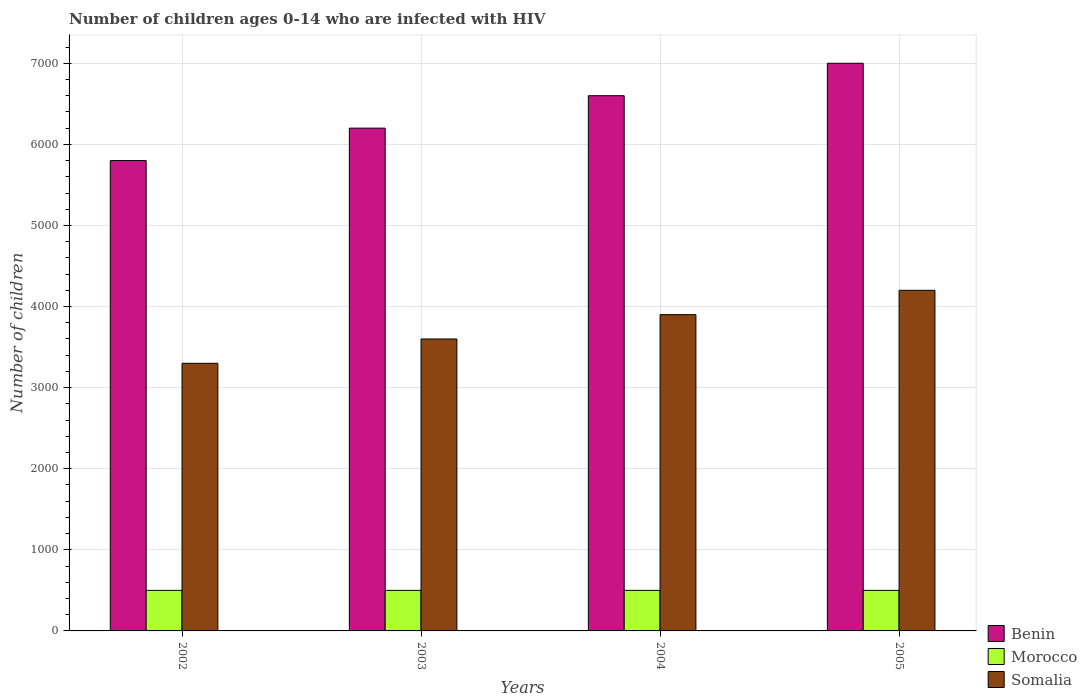How many different coloured bars are there?
Ensure brevity in your answer.  3. How many groups of bars are there?
Provide a succinct answer. 4. Are the number of bars on each tick of the X-axis equal?
Offer a terse response. Yes. How many bars are there on the 2nd tick from the right?
Your response must be concise. 3. In how many cases, is the number of bars for a given year not equal to the number of legend labels?
Provide a short and direct response. 0. What is the number of HIV infected children in Benin in 2004?
Offer a terse response. 6600. Across all years, what is the maximum number of HIV infected children in Morocco?
Your response must be concise. 500. Across all years, what is the minimum number of HIV infected children in Somalia?
Offer a very short reply. 3300. In which year was the number of HIV infected children in Benin maximum?
Offer a very short reply. 2005. What is the total number of HIV infected children in Somalia in the graph?
Provide a succinct answer. 1.50e+04. What is the difference between the number of HIV infected children in Benin in 2003 and that in 2005?
Keep it short and to the point. -800. What is the difference between the number of HIV infected children in Morocco in 2003 and the number of HIV infected children in Benin in 2004?
Give a very brief answer. -6100. What is the average number of HIV infected children in Somalia per year?
Give a very brief answer. 3750. In the year 2005, what is the difference between the number of HIV infected children in Somalia and number of HIV infected children in Benin?
Your response must be concise. -2800. What is the ratio of the number of HIV infected children in Morocco in 2002 to that in 2003?
Ensure brevity in your answer.  1. Is the difference between the number of HIV infected children in Somalia in 2002 and 2004 greater than the difference between the number of HIV infected children in Benin in 2002 and 2004?
Offer a terse response. Yes. What is the difference between the highest and the second highest number of HIV infected children in Morocco?
Provide a short and direct response. 0. What is the difference between the highest and the lowest number of HIV infected children in Morocco?
Provide a succinct answer. 0. In how many years, is the number of HIV infected children in Somalia greater than the average number of HIV infected children in Somalia taken over all years?
Offer a terse response. 2. What does the 3rd bar from the left in 2005 represents?
Your response must be concise. Somalia. What does the 1st bar from the right in 2005 represents?
Give a very brief answer. Somalia. Is it the case that in every year, the sum of the number of HIV infected children in Somalia and number of HIV infected children in Benin is greater than the number of HIV infected children in Morocco?
Give a very brief answer. Yes. How many bars are there?
Your answer should be very brief. 12. How many legend labels are there?
Keep it short and to the point. 3. How are the legend labels stacked?
Keep it short and to the point. Vertical. What is the title of the graph?
Make the answer very short. Number of children ages 0-14 who are infected with HIV. What is the label or title of the Y-axis?
Provide a succinct answer. Number of children. What is the Number of children of Benin in 2002?
Make the answer very short. 5800. What is the Number of children of Somalia in 2002?
Provide a short and direct response. 3300. What is the Number of children of Benin in 2003?
Provide a succinct answer. 6200. What is the Number of children in Morocco in 2003?
Give a very brief answer. 500. What is the Number of children in Somalia in 2003?
Keep it short and to the point. 3600. What is the Number of children of Benin in 2004?
Your answer should be very brief. 6600. What is the Number of children of Somalia in 2004?
Your answer should be very brief. 3900. What is the Number of children in Benin in 2005?
Provide a succinct answer. 7000. What is the Number of children of Somalia in 2005?
Give a very brief answer. 4200. Across all years, what is the maximum Number of children of Benin?
Provide a succinct answer. 7000. Across all years, what is the maximum Number of children of Somalia?
Ensure brevity in your answer.  4200. Across all years, what is the minimum Number of children in Benin?
Your response must be concise. 5800. Across all years, what is the minimum Number of children in Morocco?
Keep it short and to the point. 500. Across all years, what is the minimum Number of children in Somalia?
Provide a short and direct response. 3300. What is the total Number of children of Benin in the graph?
Provide a succinct answer. 2.56e+04. What is the total Number of children of Somalia in the graph?
Make the answer very short. 1.50e+04. What is the difference between the Number of children in Benin in 2002 and that in 2003?
Offer a very short reply. -400. What is the difference between the Number of children in Somalia in 2002 and that in 2003?
Give a very brief answer. -300. What is the difference between the Number of children of Benin in 2002 and that in 2004?
Your answer should be compact. -800. What is the difference between the Number of children in Morocco in 2002 and that in 2004?
Provide a short and direct response. 0. What is the difference between the Number of children in Somalia in 2002 and that in 2004?
Provide a succinct answer. -600. What is the difference between the Number of children of Benin in 2002 and that in 2005?
Your answer should be compact. -1200. What is the difference between the Number of children in Somalia in 2002 and that in 2005?
Ensure brevity in your answer.  -900. What is the difference between the Number of children in Benin in 2003 and that in 2004?
Make the answer very short. -400. What is the difference between the Number of children of Morocco in 2003 and that in 2004?
Offer a very short reply. 0. What is the difference between the Number of children in Somalia in 2003 and that in 2004?
Make the answer very short. -300. What is the difference between the Number of children in Benin in 2003 and that in 2005?
Make the answer very short. -800. What is the difference between the Number of children in Somalia in 2003 and that in 2005?
Keep it short and to the point. -600. What is the difference between the Number of children of Benin in 2004 and that in 2005?
Provide a succinct answer. -400. What is the difference between the Number of children of Somalia in 2004 and that in 2005?
Offer a very short reply. -300. What is the difference between the Number of children in Benin in 2002 and the Number of children in Morocco in 2003?
Give a very brief answer. 5300. What is the difference between the Number of children of Benin in 2002 and the Number of children of Somalia in 2003?
Make the answer very short. 2200. What is the difference between the Number of children of Morocco in 2002 and the Number of children of Somalia in 2003?
Your answer should be compact. -3100. What is the difference between the Number of children of Benin in 2002 and the Number of children of Morocco in 2004?
Offer a terse response. 5300. What is the difference between the Number of children of Benin in 2002 and the Number of children of Somalia in 2004?
Make the answer very short. 1900. What is the difference between the Number of children in Morocco in 2002 and the Number of children in Somalia in 2004?
Your answer should be compact. -3400. What is the difference between the Number of children of Benin in 2002 and the Number of children of Morocco in 2005?
Offer a terse response. 5300. What is the difference between the Number of children in Benin in 2002 and the Number of children in Somalia in 2005?
Your response must be concise. 1600. What is the difference between the Number of children in Morocco in 2002 and the Number of children in Somalia in 2005?
Make the answer very short. -3700. What is the difference between the Number of children in Benin in 2003 and the Number of children in Morocco in 2004?
Offer a very short reply. 5700. What is the difference between the Number of children in Benin in 2003 and the Number of children in Somalia in 2004?
Your answer should be very brief. 2300. What is the difference between the Number of children in Morocco in 2003 and the Number of children in Somalia in 2004?
Ensure brevity in your answer.  -3400. What is the difference between the Number of children of Benin in 2003 and the Number of children of Morocco in 2005?
Your answer should be very brief. 5700. What is the difference between the Number of children in Morocco in 2003 and the Number of children in Somalia in 2005?
Your answer should be compact. -3700. What is the difference between the Number of children in Benin in 2004 and the Number of children in Morocco in 2005?
Provide a succinct answer. 6100. What is the difference between the Number of children of Benin in 2004 and the Number of children of Somalia in 2005?
Provide a short and direct response. 2400. What is the difference between the Number of children of Morocco in 2004 and the Number of children of Somalia in 2005?
Make the answer very short. -3700. What is the average Number of children of Benin per year?
Offer a terse response. 6400. What is the average Number of children in Somalia per year?
Offer a very short reply. 3750. In the year 2002, what is the difference between the Number of children of Benin and Number of children of Morocco?
Give a very brief answer. 5300. In the year 2002, what is the difference between the Number of children in Benin and Number of children in Somalia?
Make the answer very short. 2500. In the year 2002, what is the difference between the Number of children in Morocco and Number of children in Somalia?
Keep it short and to the point. -2800. In the year 2003, what is the difference between the Number of children of Benin and Number of children of Morocco?
Your response must be concise. 5700. In the year 2003, what is the difference between the Number of children in Benin and Number of children in Somalia?
Give a very brief answer. 2600. In the year 2003, what is the difference between the Number of children of Morocco and Number of children of Somalia?
Provide a succinct answer. -3100. In the year 2004, what is the difference between the Number of children in Benin and Number of children in Morocco?
Offer a terse response. 6100. In the year 2004, what is the difference between the Number of children of Benin and Number of children of Somalia?
Provide a succinct answer. 2700. In the year 2004, what is the difference between the Number of children of Morocco and Number of children of Somalia?
Your answer should be compact. -3400. In the year 2005, what is the difference between the Number of children in Benin and Number of children in Morocco?
Provide a short and direct response. 6500. In the year 2005, what is the difference between the Number of children of Benin and Number of children of Somalia?
Your answer should be compact. 2800. In the year 2005, what is the difference between the Number of children of Morocco and Number of children of Somalia?
Offer a terse response. -3700. What is the ratio of the Number of children of Benin in 2002 to that in 2003?
Offer a very short reply. 0.94. What is the ratio of the Number of children in Benin in 2002 to that in 2004?
Offer a terse response. 0.88. What is the ratio of the Number of children in Morocco in 2002 to that in 2004?
Give a very brief answer. 1. What is the ratio of the Number of children in Somalia in 2002 to that in 2004?
Make the answer very short. 0.85. What is the ratio of the Number of children of Benin in 2002 to that in 2005?
Offer a terse response. 0.83. What is the ratio of the Number of children in Morocco in 2002 to that in 2005?
Give a very brief answer. 1. What is the ratio of the Number of children in Somalia in 2002 to that in 2005?
Your answer should be compact. 0.79. What is the ratio of the Number of children of Benin in 2003 to that in 2004?
Give a very brief answer. 0.94. What is the ratio of the Number of children of Somalia in 2003 to that in 2004?
Offer a terse response. 0.92. What is the ratio of the Number of children of Benin in 2003 to that in 2005?
Your response must be concise. 0.89. What is the ratio of the Number of children of Morocco in 2003 to that in 2005?
Your answer should be very brief. 1. What is the ratio of the Number of children of Benin in 2004 to that in 2005?
Make the answer very short. 0.94. What is the difference between the highest and the second highest Number of children in Morocco?
Give a very brief answer. 0. What is the difference between the highest and the second highest Number of children of Somalia?
Your answer should be compact. 300. What is the difference between the highest and the lowest Number of children of Benin?
Give a very brief answer. 1200. What is the difference between the highest and the lowest Number of children in Somalia?
Offer a very short reply. 900. 